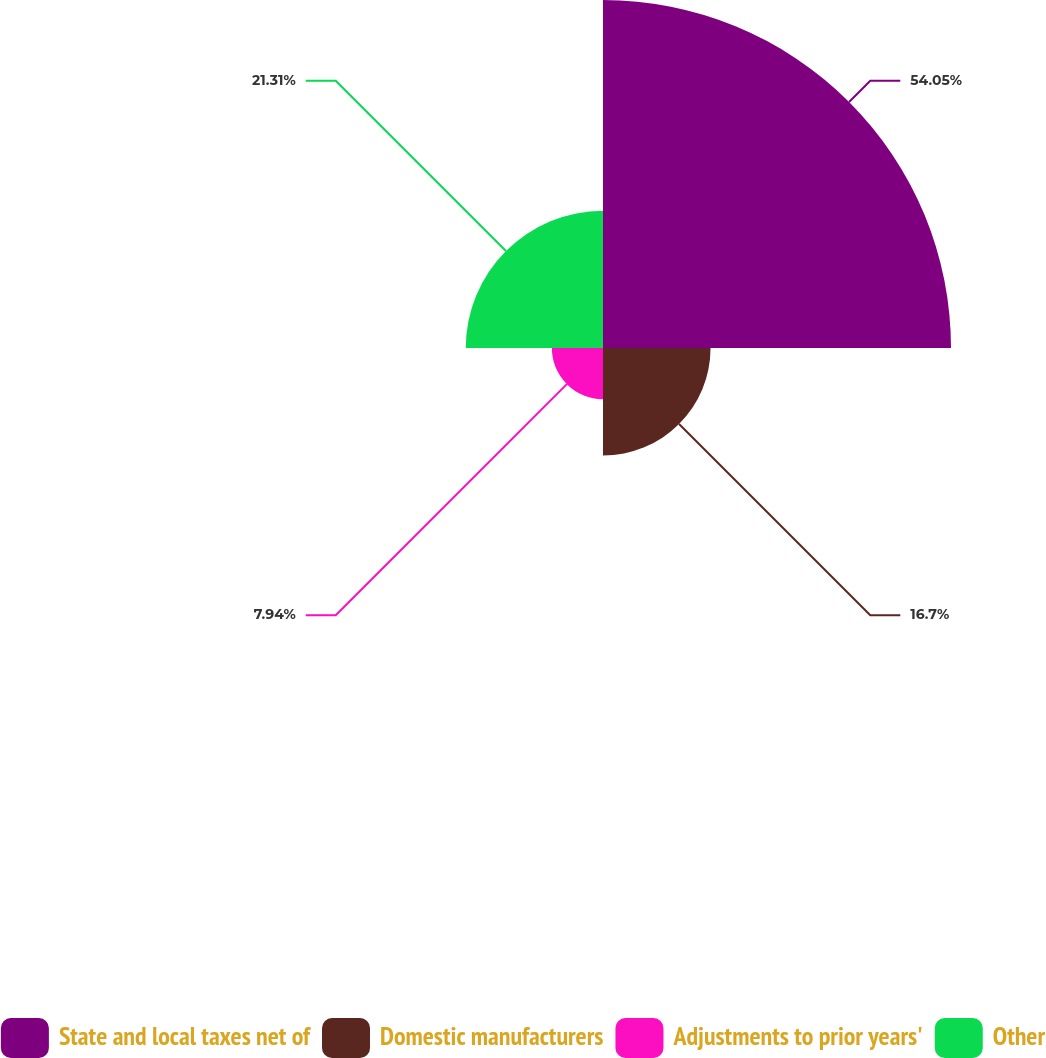Convert chart. <chart><loc_0><loc_0><loc_500><loc_500><pie_chart><fcel>State and local taxes net of<fcel>Domestic manufacturers<fcel>Adjustments to prior years'<fcel>Other<nl><fcel>54.04%<fcel>16.7%<fcel>7.94%<fcel>21.31%<nl></chart> 